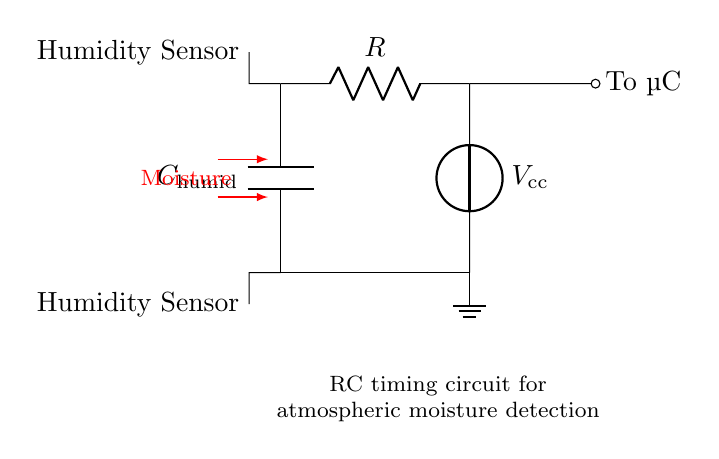What type of sensor is used in this circuit? The circuit contains a capacitive humidity sensor, which is indicated by the labeling and typical application of capacitive sensors in humidity detection.
Answer: Capacitive humidity sensor What does the capacitor represent in the circuit? The capacitor, labeled as C humid, represents the component that stores electrical charge and varies its capacitance based on moisture levels. This is characteristic of capacitive humidity sensors.
Answer: Capacitor What is the function of the resistor labeled R? The resistor R, in conjunction with the capacitor, creates an RC timing circuit that affects the charge and discharge rates of the capacitor, which is crucial for detecting atmospheric moisture levels.
Answer: Timing What is the voltage source labeled V cc? The voltage source labeled V cc provides the necessary power supply for the circuit, enabling it to operate and process signals from the humidity sensor.
Answer: Power supply How does moisture affect the capacitor in the circuit? Moisture increases the capacitance of the capacitor, leading to changes in the charging and discharging behavior of the RC circuit, which can be detected by the connected microcontroller for humidity measurement.
Answer: Capacitance increase What is the purpose of the output labeled "To µC"? The output labeled "To µC" indicates that the charge or voltage across the capacitor will be sent to a microcontroller for processing the humidity data, making it essential for electronic measurement and control.
Answer: Data output How does the RC timing aspect relate to moisture detection? The RC timing aspect determines how quickly the circuit responds to changes in humidity. As the capacitance changes due to humidity variations, the time constant of the circuit (RC) dictates the sensitivity and response time for detecting atmospheric moisture.
Answer: Response time 